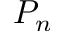Convert formula to latex. <formula><loc_0><loc_0><loc_500><loc_500>P _ { n }</formula> 